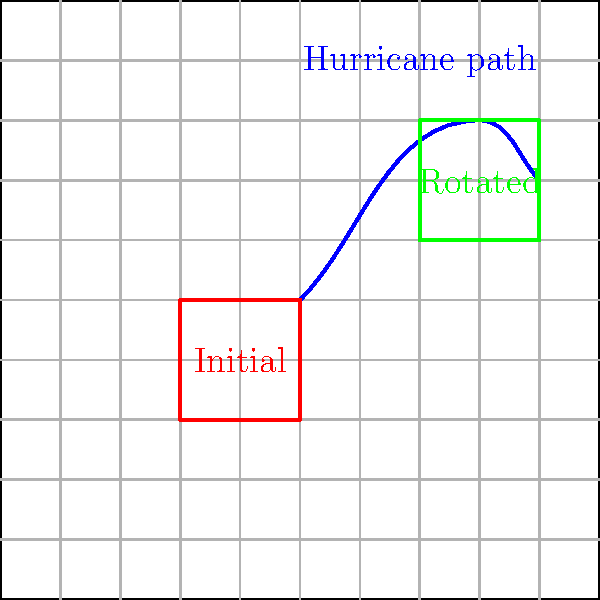A satellite image tracking a hurricane's path is initially positioned as shown in red. After the hurricane moves along the blue path, the image needs to be rotated and repositioned to capture the new location, as shown in green. What is the angle of rotation (in degrees) and the translation vector required to transform the initial image to its new position? To solve this problem, we need to follow these steps:

1. Determine the angle of rotation:
   - The initial image is aligned with the x and y axes.
   - The rotated image is tilted at a 45-degree angle.
   - Therefore, the angle of rotation is 45 degrees counterclockwise.

2. Calculate the translation vector:
   - Initial image center: $(-1, -1)$
   - Rotated image center: $(3, 2)$
   - Translation vector: $(3, 2) - (-1, -1) = (4, 3)$

3. Express the transformation:
   - Rotation: 45 degrees counterclockwise
   - Translation: vector $(4, 3)$

The complete transformation can be described as a rotation of 45 degrees counterclockwise followed by a translation of 4 units in the x-direction and 3 units in the y-direction.
Answer: 45°, $(4, 3)$ 